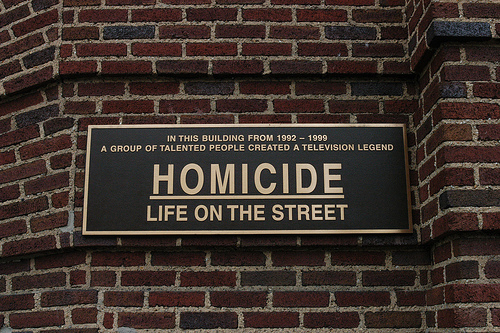<image>
Can you confirm if the homicide sign is on the wall? Yes. Looking at the image, I can see the homicide sign is positioned on top of the wall, with the wall providing support. 